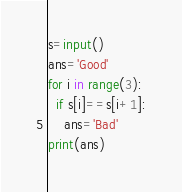Convert code to text. <code><loc_0><loc_0><loc_500><loc_500><_Python_>s=input()
ans='Good'
for i in range(3):
  if s[i]==s[i+1]:
    ans='Bad'
print(ans)
</code> 